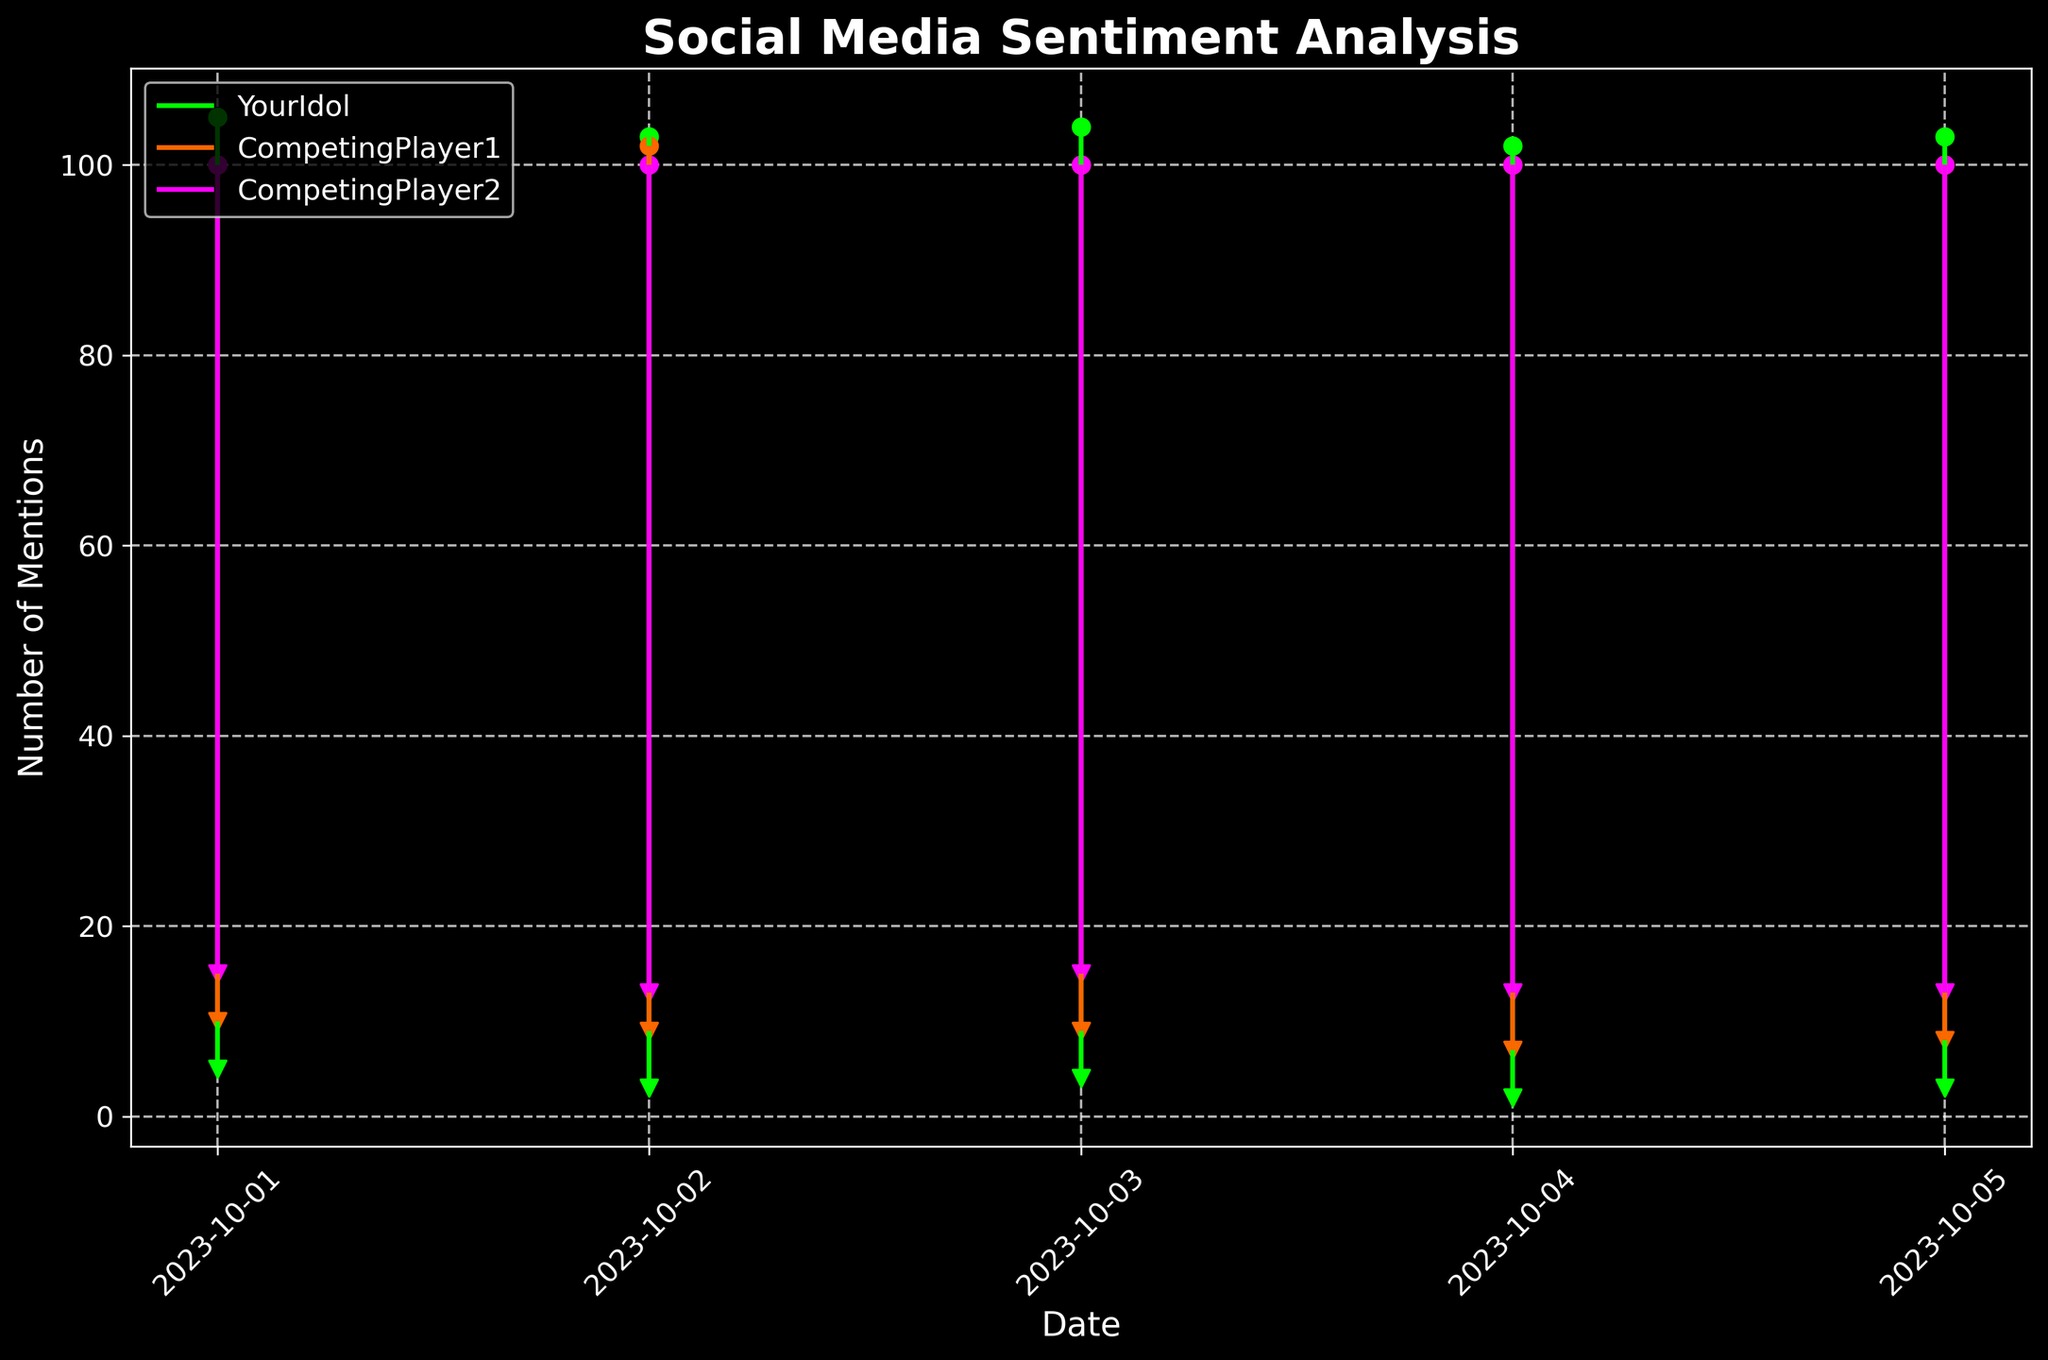What's the title of the figure? The title of the figure is the text displayed at the top, usually in larger and bold font.
Answer: Social Media Sentiment Analysis How many players are included in the analysis? By counting the distinct labels in the legend, we can determine the number of players.
Answer: 3 What color represents YourIdol in the plot? The color representing YourIdol can be identified by matching the legend to its visual representation in the plot.
Answer: Green On which date does YourIdol have the highest positive mentions? By examining the position and length of the corresponding candlesticks, we can pinpoint the date where the highest positive mentions occurred. On Oct 5, YourIdol's vline is the highest.
Answer: 2023-10-05 Which player has the most negative mentions on 2023-10-03? By examining the bottom part of the candlesticks for each player on Oct 3, we can find the lowest points indicating negative mentions.
Answer: CompetingPlayer2 What's the total number of mentions for YourIdol on 2023-10-02? Sum the values of positive, neutral, and negative mentions for YourIdol on Oct 2.
Answer: 103 How many more positive mentions does YourIdol have than CompetingPlayer2 on 2023-10-05? Subtract CompetingPlayer2's positive mentions from YourIdol's positive mentions on Oct 5. 94 (YourIdol) - 69 (CompetingPlayer2).
Answer: 25 What's the average number of daily positive mentions for CompetingPlayer1? Sum the positive mentions for CompetingPlayer1 across all dates and divide by the number of dates. (70+75+72+76+73)/5 = 366/5.
Answer: 73.2 Which player has the most consistent neutral mentions in terms of visual appearance? By examining the plots, the player with the smallest variation and most uniformly sized middle segments of the candlesticks represents the most consistency in neutral mentions.
Answer: CompetingPlayer1 What’s the general trend for YourIdol's positive mentions over the dates? Observe the top part of the candlesticks corresponding to YourIdol across the dates to identify a pattern or trend. The segments are consistently increasing in length.
Answer: Increasing 